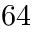Convert formula to latex. <formula><loc_0><loc_0><loc_500><loc_500>6 4</formula> 